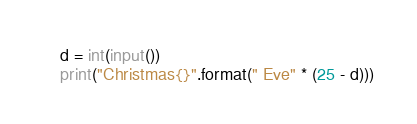Convert code to text. <code><loc_0><loc_0><loc_500><loc_500><_Python_>d = int(input())
print("Christmas{}".format(" Eve" * (25 - d)))</code> 